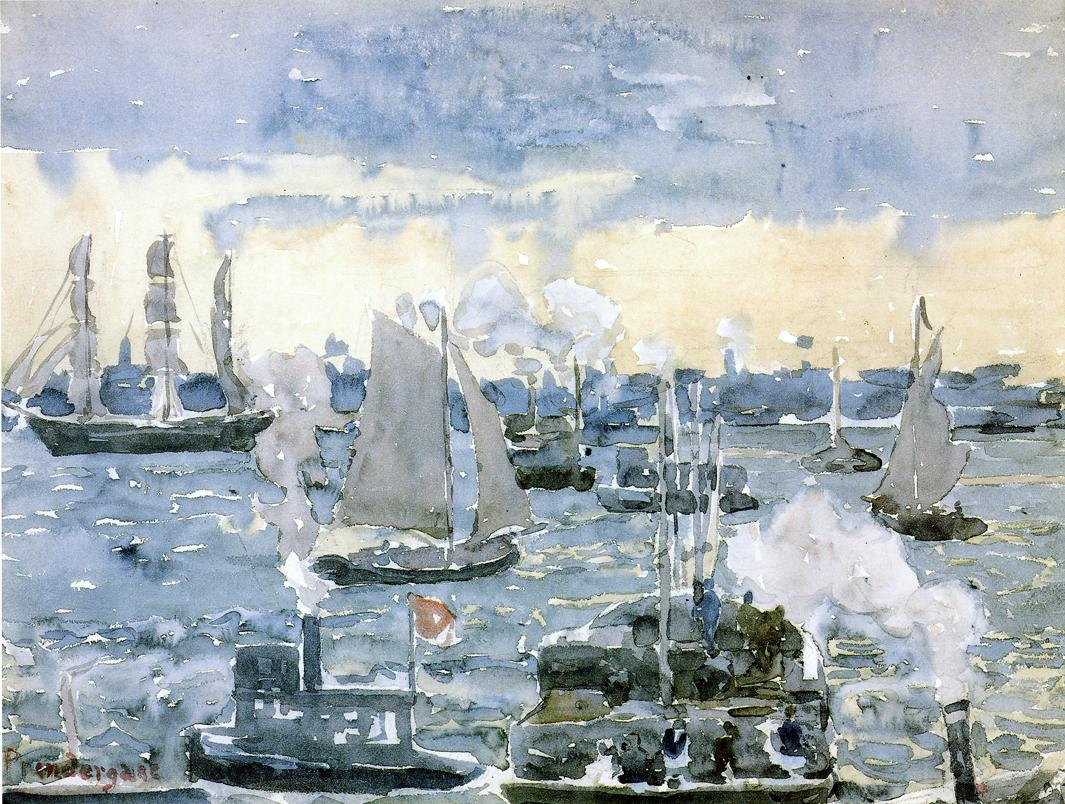Is there any significance to the way light is portrayed in this painting? Yes, the portrayal of light in this painting is very significant. The artist uses light to create a sense of atmosphere and mood, diffusing it through a cloudy sky that casts a soft, almost ethereal glow over the harbor. This diffused light affects the way colors are perceived, blending blues, whites, greens, and browns into a harmonious palette that evokes calm and continuity. The shimmering reflection on the water’s surface mirrors the sky, further enhancing the tranquil yet dynamic feel of the scene. This manipulation of light is a hallmark of impressionist technique, aiming to capture the ephemeral quality of the moment and the natural interplay of light and shadow. Can you imagine a story where the harbor suddenly turns into a bustling space port? Describe it. In an alternate reality, this tranquil harbor morphs into a bustling spaceport. Towering starships, with sleek, reflective exteriors, replace the traditional boats, their engines humming with a low, powerful energy. The billowing sails transform into solar collectors, capturing the energy from distant stars. Smoke from the steamships is now the vibrant, neon exhaust of interstellar vessels prepping for warp speed. The waters below are dotted with small submersibles and aquatic drones, maintaining installations and collecting oceanic data for interplanetary travel. Dock workers clad in futuristic suits, assisted by autonomous robots, bustle around, loading and unloading precious cargo destined for far-flung planets. Communication towers with rotating satellite dishes, intricate cables, and beams of light stretching out into the cosmos mark the skyline. The air hums with the sounds of alien languages, and the scent of exotic spices and minerals from distant worlds pervades the atmosphere. This is no longer a simple harbor; it is now a gateway to the universe, where the spirit of exploration and adventure thrives, amidst the roots of humanity's maritime past. 